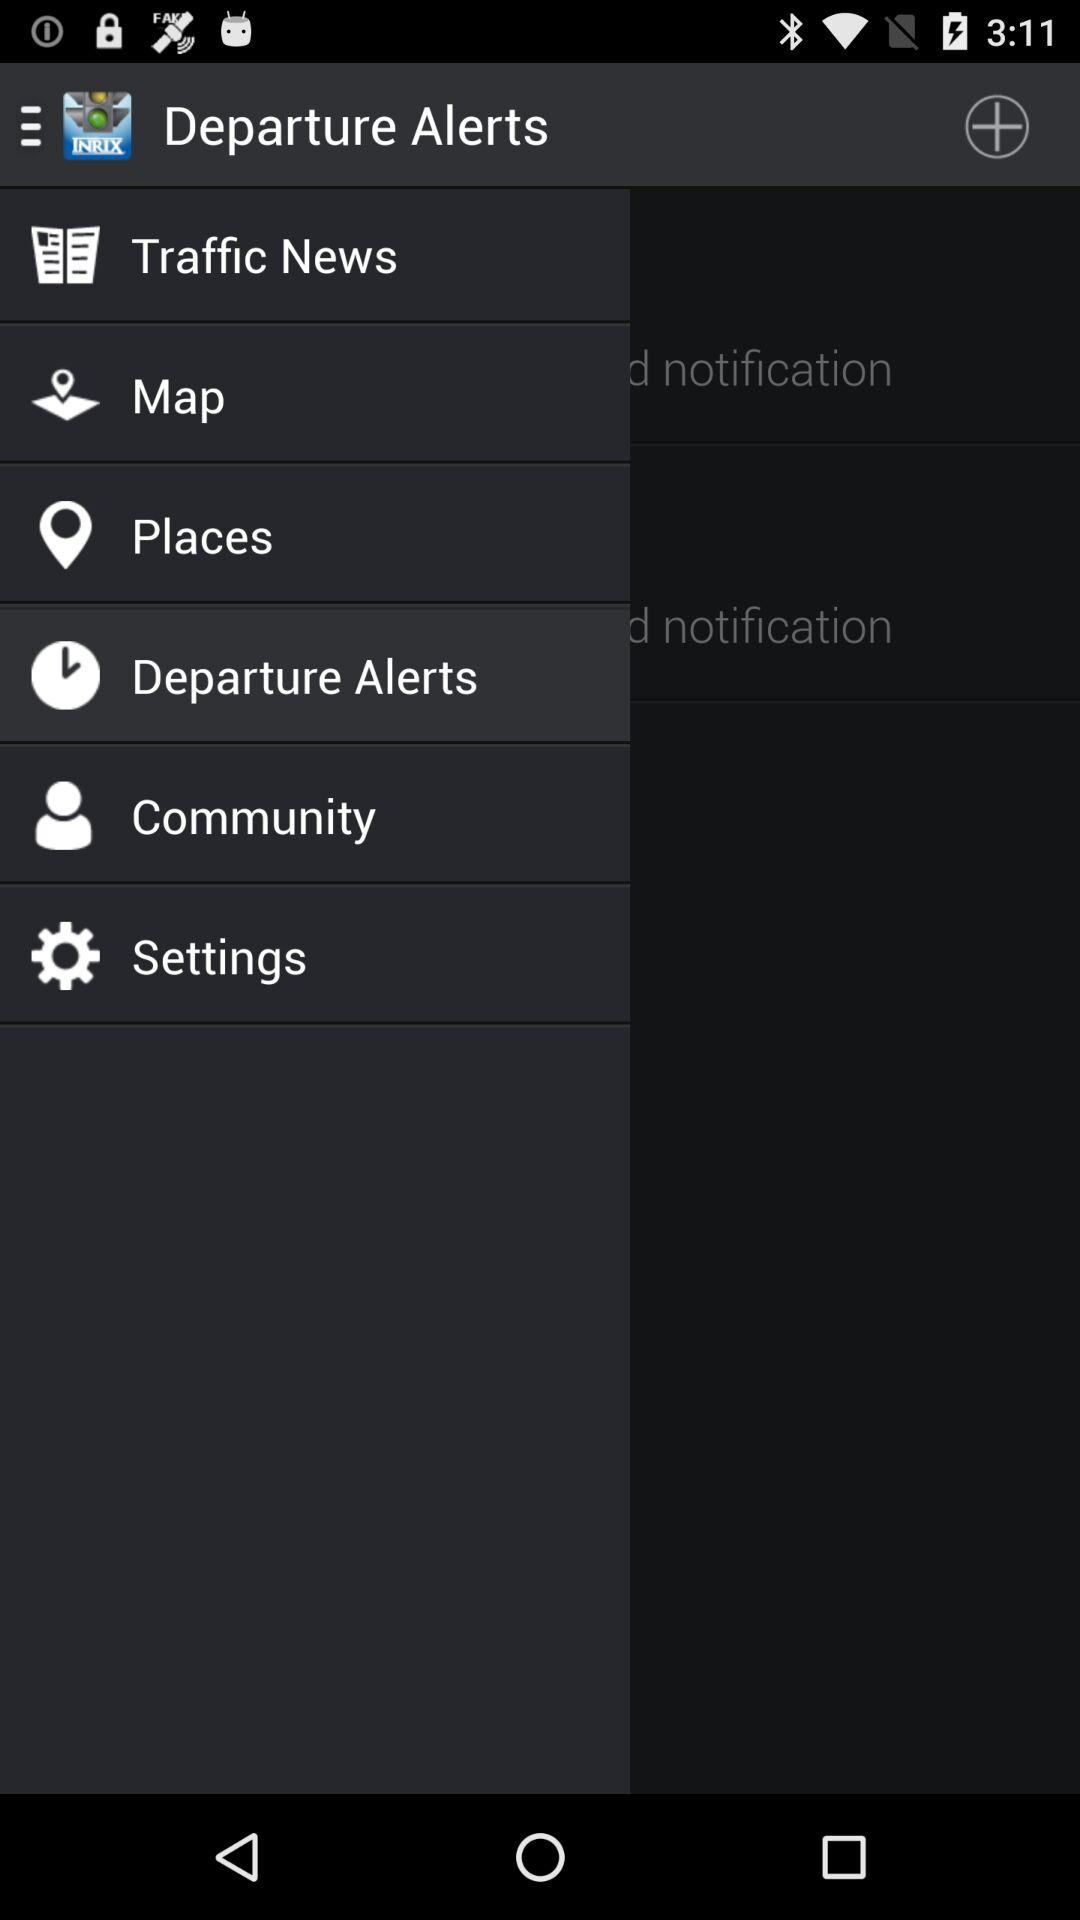How many notifications do I have?
Answer the question using a single word or phrase. 2 